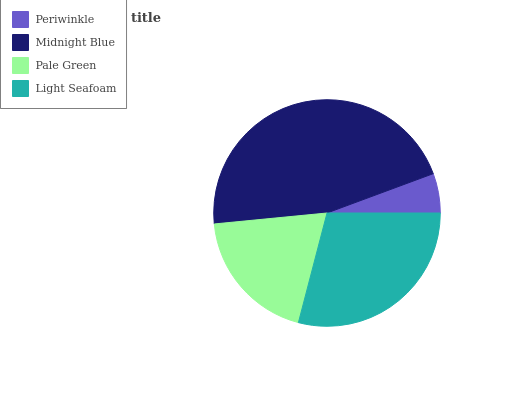Is Periwinkle the minimum?
Answer yes or no. Yes. Is Midnight Blue the maximum?
Answer yes or no. Yes. Is Pale Green the minimum?
Answer yes or no. No. Is Pale Green the maximum?
Answer yes or no. No. Is Midnight Blue greater than Pale Green?
Answer yes or no. Yes. Is Pale Green less than Midnight Blue?
Answer yes or no. Yes. Is Pale Green greater than Midnight Blue?
Answer yes or no. No. Is Midnight Blue less than Pale Green?
Answer yes or no. No. Is Light Seafoam the high median?
Answer yes or no. Yes. Is Pale Green the low median?
Answer yes or no. Yes. Is Pale Green the high median?
Answer yes or no. No. Is Midnight Blue the low median?
Answer yes or no. No. 